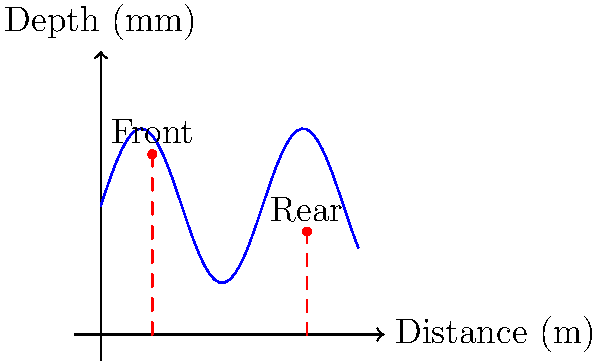A suspect's vehicle left distinctive tire tracks at a crime scene. The graph shows the depth profile of the tire tread pattern over a 10-meter distance, along with indicators of weight distribution between the front and rear axles. Given that the tire tread depth follows the function $d(x) = 5 + 3\sin(x)$ mm, where $x$ is the distance in meters, and the weight distribution is represented by the vertical red lines, calculate the difference in average tread depth between the front and rear axles. How might this information be useful in your investigation? To solve this problem, we'll follow these steps:

1) The tire tread depth function is given as $d(x) = 5 + 3\sin(x)$ mm.

2) From the graph, we can see that the front axle is at $x = 2$ m and the rear axle is at $x = 8$ m.

3) To find the tread depth at the front axle:
   $d(2) = 5 + 3\sin(2) \approx 6.82$ mm

4) To find the tread depth at the rear axle:
   $d(8) = 5 + 3\sin(8) \approx 3.18$ mm

5) The difference in tread depth:
   $6.82 - 3.18 = 3.64$ mm

This information could be useful in the investigation for several reasons:
- It provides a unique identifier for the suspect's vehicle.
- The difference in tread depth between front and rear axles can indicate the vehicle's weight distribution, potentially giving clues about its make and model.
- The specific tread pattern and depth could be matched to tracks left at other crime scenes, potentially linking multiple incidents.
- The weight distribution could indicate if the vehicle was carrying a heavy load, which might be relevant to smuggling activities.
Answer: 3.64 mm difference; aids in vehicle identification and potential linking of crime scenes. 